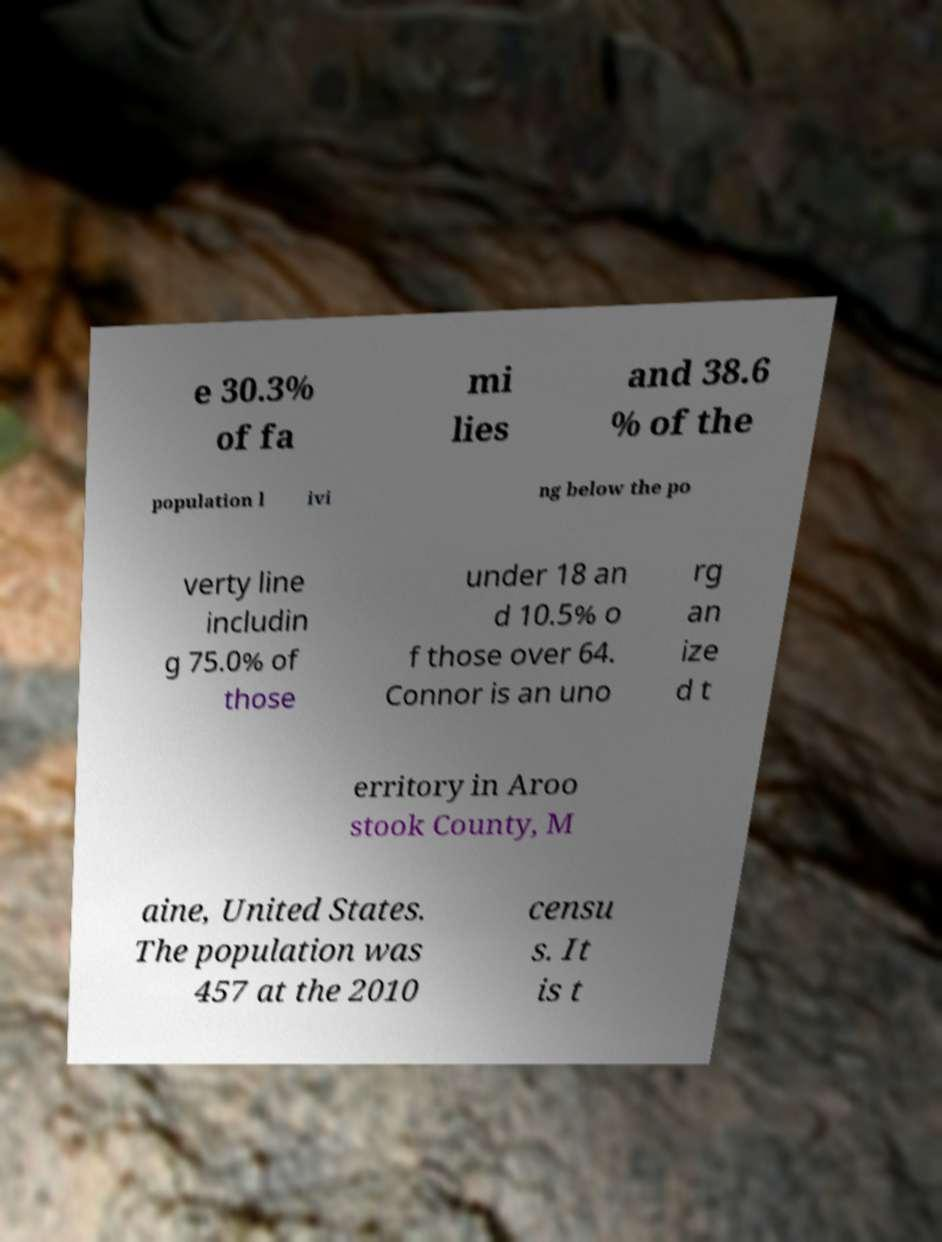Can you accurately transcribe the text from the provided image for me? e 30.3% of fa mi lies and 38.6 % of the population l ivi ng below the po verty line includin g 75.0% of those under 18 an d 10.5% o f those over 64. Connor is an uno rg an ize d t erritory in Aroo stook County, M aine, United States. The population was 457 at the 2010 censu s. It is t 